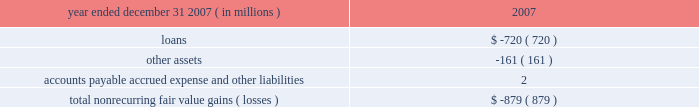Jpmorgan chase & co .
/ 2007 annual report 117 nonrecurring fair value changes the table presents the total change in value of financial instruments for which a fair value adjustment has been included in the consolidated statement of income for the year ended december 31 , 2007 , related to financial instruments held at december 31 , 2007 .
Year ended december 31 , 2007 ( in millions ) 2007 .
In the above table , loans principally include changes in fair value for loans carried on the balance sheet at the lower of cost or fair value ; and accounts payable , accrued expense and other liabilities principally includes the change in fair value for unfunded lending-related commitments within the leveraged lending portfolio .
Level 3 assets analysis level 3 assets ( including assets measured at the lower of cost or fair value ) were 5% ( 5 % ) of total firm assets at december 31 , 2007 .
These assets increased during 2007 principally during the second half of the year , when liquidity in mortgages and other credit products fell dra- matically .
The increase was primarily due to an increase in leveraged loan balances within level 3 as the ability of the firm to syndicate this risk to third parties became limited by the credit environment .
In addi- tion , there were transfers from level 2 to level 3 during 2007 .
These transfers were principally for instruments within the mortgage market where inputs which are significant to their valuation became unob- servable during the year .
Subprime and alt-a whole loans , subprime home equity securities , commercial mortgage-backed mezzanine loans and credit default swaps referenced to asset-backed securities consti- tuted the majority of the affected instruments , reflecting a significant decline in liquidity in these instruments in the third and fourth quarters of 2007 , as new issue activity was nonexistent and independent pric- ing information was no longer available for these assets .
Transition in connection with the initial adoption of sfas 157 , the firm recorded the following on january 1 , 2007 : 2022 a cumulative effect increase to retained earnings of $ 287 million , primarily related to the release of profit previously deferred in accordance with eitf 02-3 ; 2022 an increase to pretax income of $ 166 million ( $ 103 million after-tax ) related to the incorporation of the firm 2019s creditworthiness in the valuation of liabilities recorded at fair value ; and 2022 an increase to pretax income of $ 464 million ( $ 288 million after-tax ) related to valuations of nonpublic private equity investments .
Prior to the adoption of sfas 157 , the firm applied the provisions of eitf 02-3 to its derivative portfolio .
Eitf 02-3 precluded the recogni- tion of initial trading profit in the absence of : ( a ) quoted market prices , ( b ) observable prices of other current market transactions or ( c ) other observable data supporting a valuation technique .
In accor- dance with eitf 02-3 , the firm recognized the deferred profit in principal transactions revenue on a systematic basis ( typically straight- line amortization over the life of the instruments ) and when observ- able market data became available .
Prior to the adoption of sfas 157 the firm did not incorporate an adjustment into the valuation of liabilities carried at fair value on the consolidated balance sheet .
Commencing january 1 , 2007 , in accor- dance with the requirements of sfas 157 , an adjustment was made to the valuation of liabilities measured at fair value to reflect the credit quality of the firm .
Prior to the adoption of sfas 157 , privately held investments were initially valued based upon cost .
The carrying values of privately held investments were adjusted from cost to reflect both positive and neg- ative changes evidenced by financing events with third-party capital providers .
The investments were also subject to ongoing impairment reviews by private equity senior investment professionals .
The increase in pretax income related to nonpublic private equity investments in connection with the adoption of sfas 157 was due to there being sufficient market evidence to support an increase in fair values using the sfas 157 methodology , although there had not been an actual third-party market transaction related to such investments .
Financial disclosures required by sfas 107 sfas 107 requires disclosure of the estimated fair value of certain financial instruments and the methods and significant assumptions used to estimate their fair values .
Many but not all of the financial instruments held by the firm are recorded at fair value on the consolidated balance sheets .
Financial instruments within the scope of sfas 107 that are not carried at fair value on the consolidated balance sheets are discussed below .
Additionally , certain financial instruments and all nonfinancial instruments are excluded from the scope of sfas 107 .
Accordingly , the fair value disclosures required by sfas 107 provide only a partial estimate of the fair value of jpmorgan chase .
For example , the firm has developed long-term relationships with its customers through its deposit base and credit card accounts , commonly referred to as core deposit intangibles and credit card relationships .
In the opinion of management , these items , in the aggregate , add significant value to jpmorgan chase , but their fair value is not disclosed in this note .
Financial instruments for which fair value approximates carrying value certain financial instruments that are not carried at fair value on the consolidated balance sheets are carried at amounts that approxi- mate fair value due to their short-term nature and generally negligi- ble credit risk .
These instruments include cash and due from banks , deposits with banks , federal funds sold , securities purchased under resale agreements with short-dated maturities , securities borrowed , short-term receivables and accrued interest receivable , commercial paper , federal funds purchased , securities sold under repurchase agreements with short-dated maturities , other borrowed funds , accounts payable and accrued liabilities .
In addition , sfas 107 requires that the fair value for deposit liabilities with no stated matu- rity ( i.e. , demand , savings and certain money market deposits ) be equal to their carrying value .
Sfas 107 does not allow for the recog- nition of the inherent funding value of these instruments. .
What was the tax rate associated with the increase in retained earrings related to the incorporation of the firm 2019s creditworthiness in the valuation of liabilities recorded at fair value;? 
Computations: ((166 / 103) / 166)
Answer: 0.00971. 